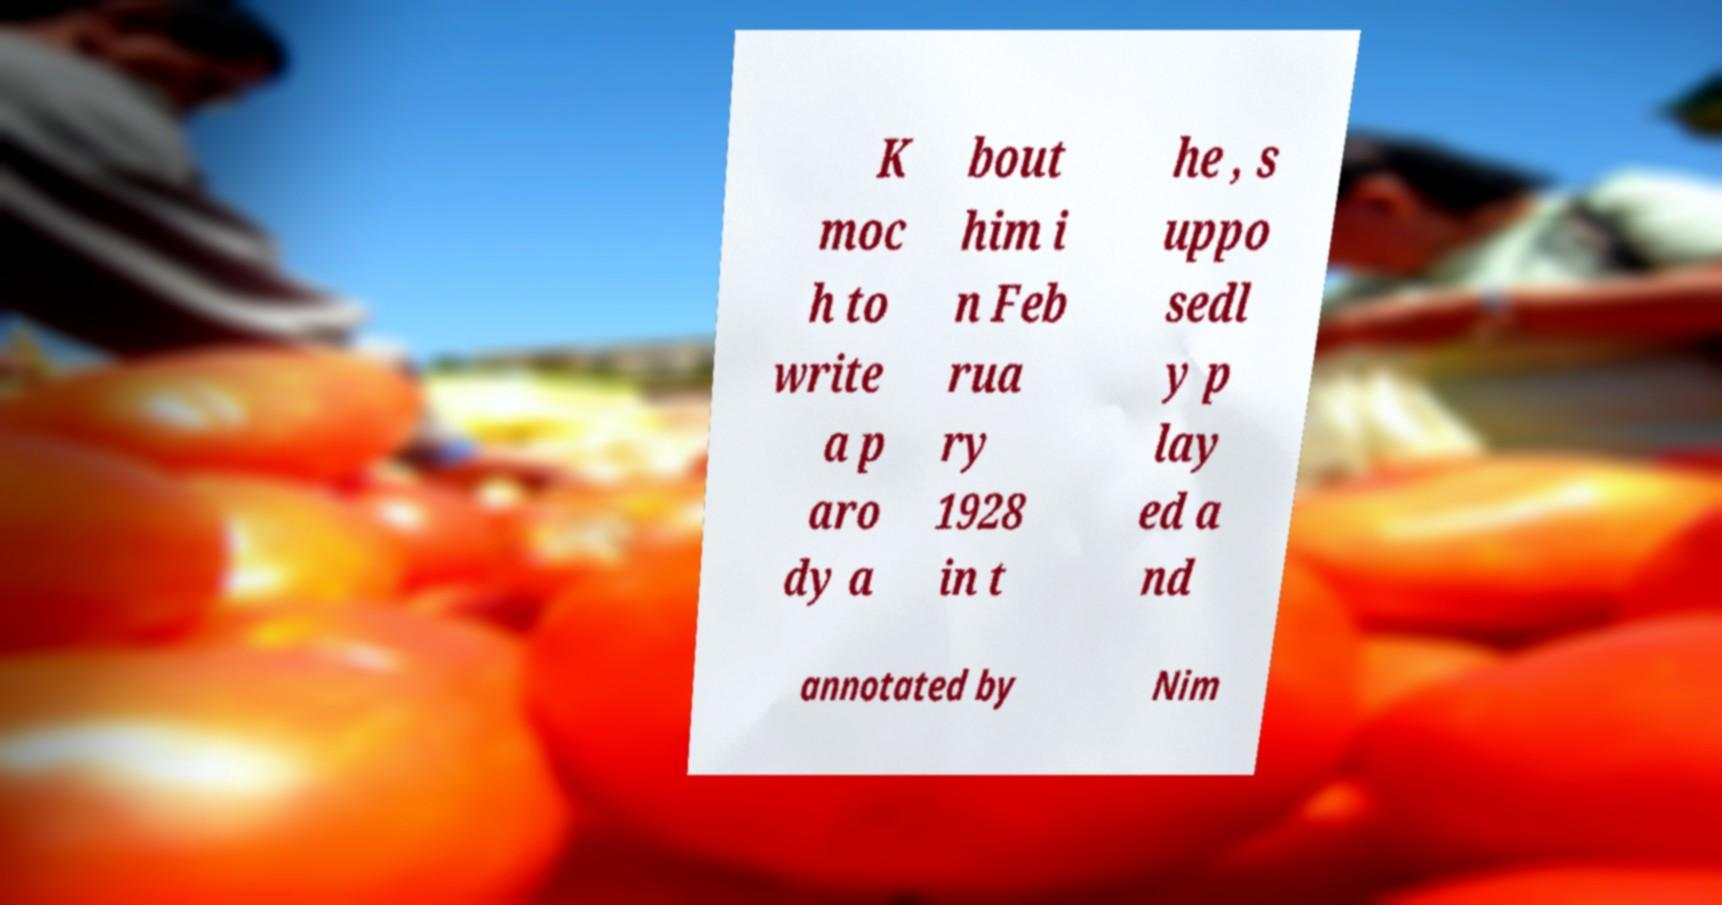I need the written content from this picture converted into text. Can you do that? K moc h to write a p aro dy a bout him i n Feb rua ry 1928 in t he , s uppo sedl y p lay ed a nd annotated by Nim 